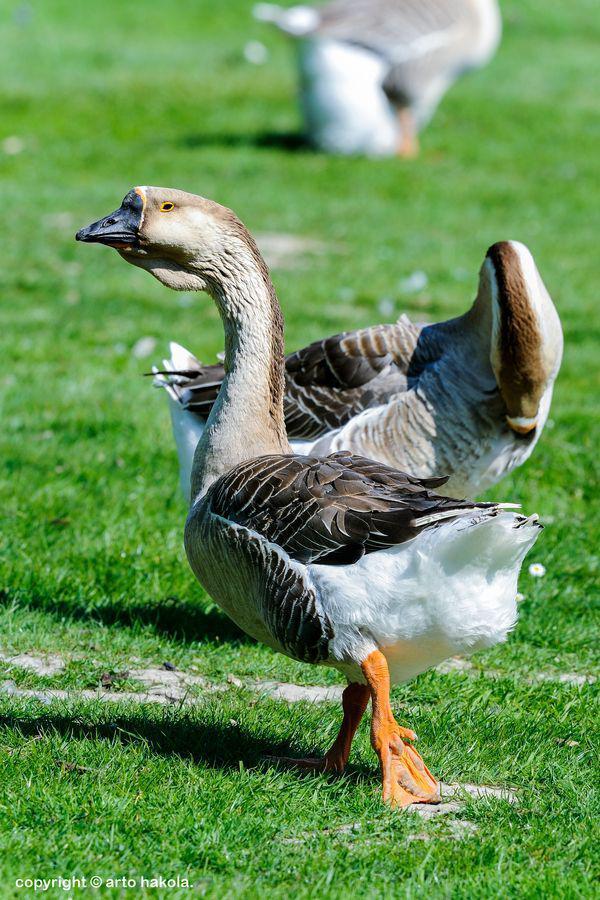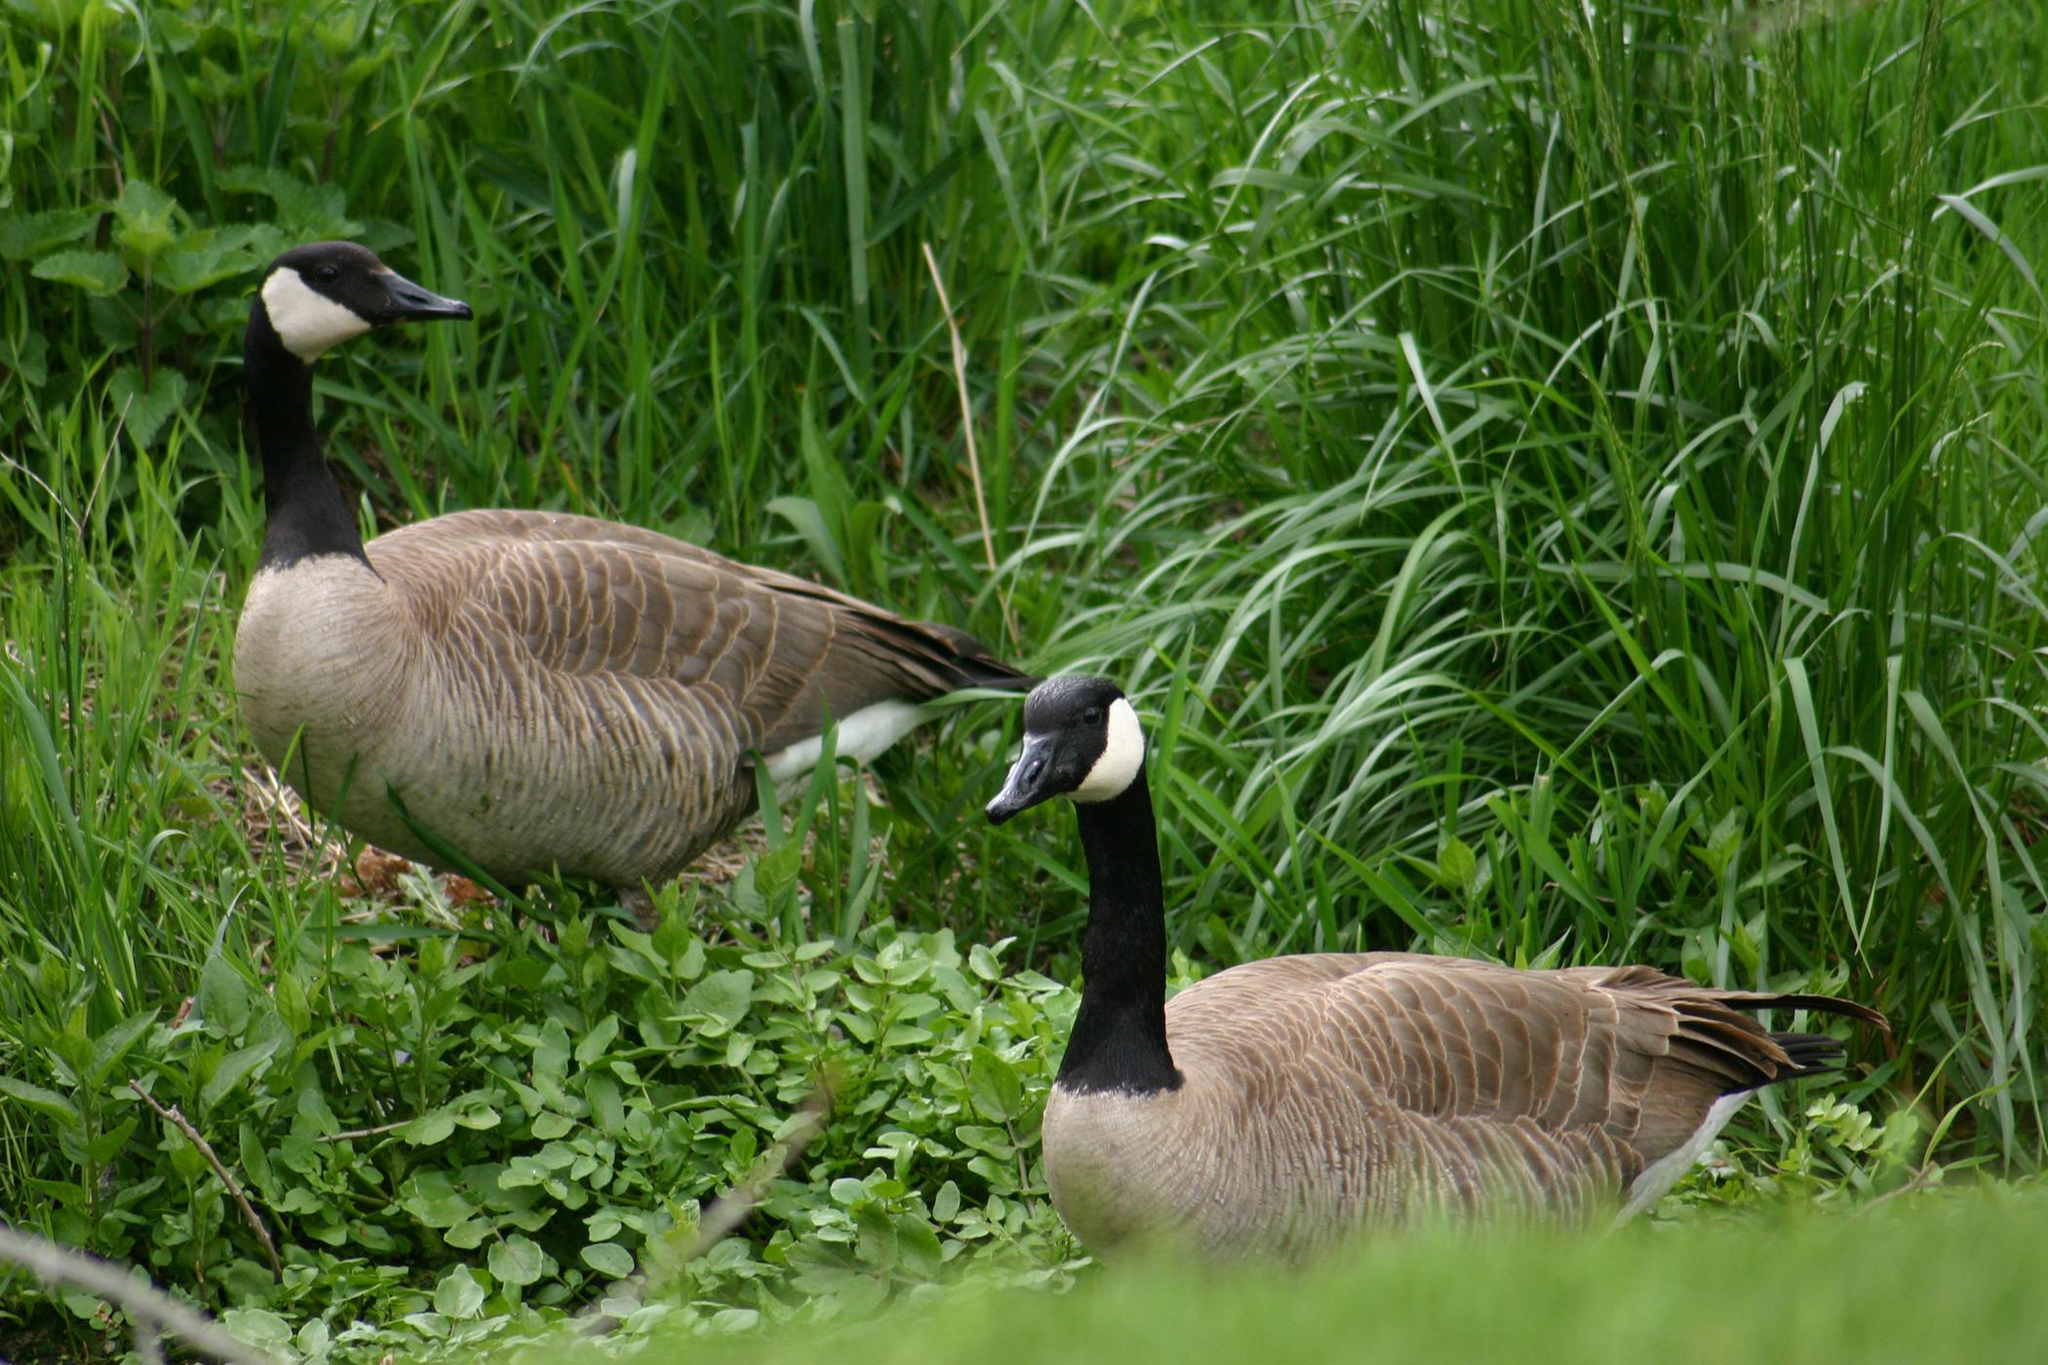The first image is the image on the left, the second image is the image on the right. Considering the images on both sides, is "An image shows two adult geese on a grassy field with multiple goslings." valid? Answer yes or no. No. The first image is the image on the left, the second image is the image on the right. For the images shown, is this caption "there are two ducks in the right image." true? Answer yes or no. Yes. 